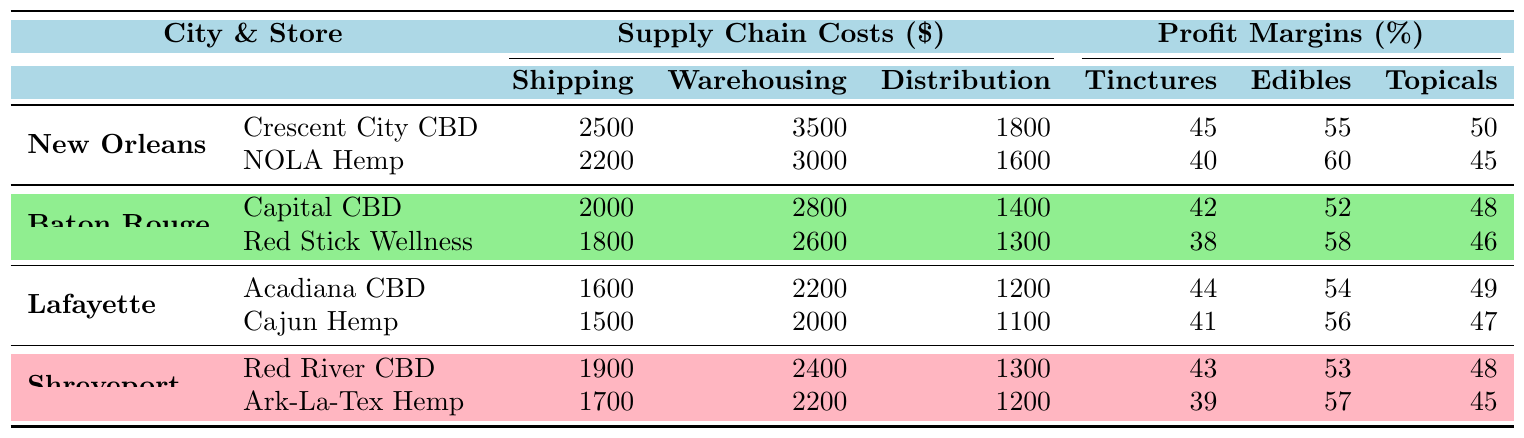What is the shipping cost for NOLA Hemp? The table shows that the shipping cost for NOLA Hemp in New Orleans is 2200.
Answer: 2200 What is the average profit margin for edibles across all retailers? To find the average profit margin for edibles, we take the sum of all profit margins for edibles (55 + 60 + 52 + 58 + 54 + 56 + 53 + 57) = 455 and divide by the number of retailers (8), giving an average of 455/8 = 56.875.
Answer: 56.88 Which store in Baton Rouge has the highest profit margin for tinctures? By reviewing the profit margins for tinctures in Baton Rouge, Capital CBD has 42 and Red Stick Wellness has 38; thus, Capital CBD has the highest profit margin for tinctures.
Answer: Capital CBD Is the total supply chain cost for Cajun Hemp higher than for Crescent City CBD? The total supply chain cost for Cajun Hemp is 1500 (Shipping) + 2000 (Warehousing) + 1100 (Distribution) = 4600, while Crescent City CBD costs 2500 + 3500 + 1800 = 7800. Since 4600 is less than 7800, the statement is false.
Answer: No What city has the lowest average warehousing costs among the retailers? The average warehousing costs can be calculated: New Orleans: (3500 + 3000)/2 = 3250, Baton Rouge: (2800 + 2600)/2 = 2700, Lafayette: (2200 + 2000)/2 = 2100, Shreveport: (2400 + 2200)/2 = 2300. Thus, Lafayette has the lowest average warehousing cost at 2100.
Answer: Lafayette Which product category has the highest profit margin overall across all cities? By summing up the profit margins per product category across all retailers: Tinctures = 45 + 40 + 42 + 38 + 44 + 41 + 43 + 39 = 392; Edibles = 55 + 60 + 52 + 58 + 54 + 56 + 53 + 57 = 455; Topicals = 50 + 45 + 48 + 46 + 49 + 47 + 48 + 45 = 378. The highest sum is for Edibles.
Answer: Edibles Which city has the highest shipping costs summed across all its retailers? New Orleans has shipping costs of 2500 + 2200 = 4700, Baton Rouge has 2000 + 1800 = 3800, Lafayette has 1600 + 1500 = 3100, and Shreveport has 1900 + 1700 = 3600. Therefore, New Orleans has the highest total shipping cost of 4700.
Answer: New Orleans 